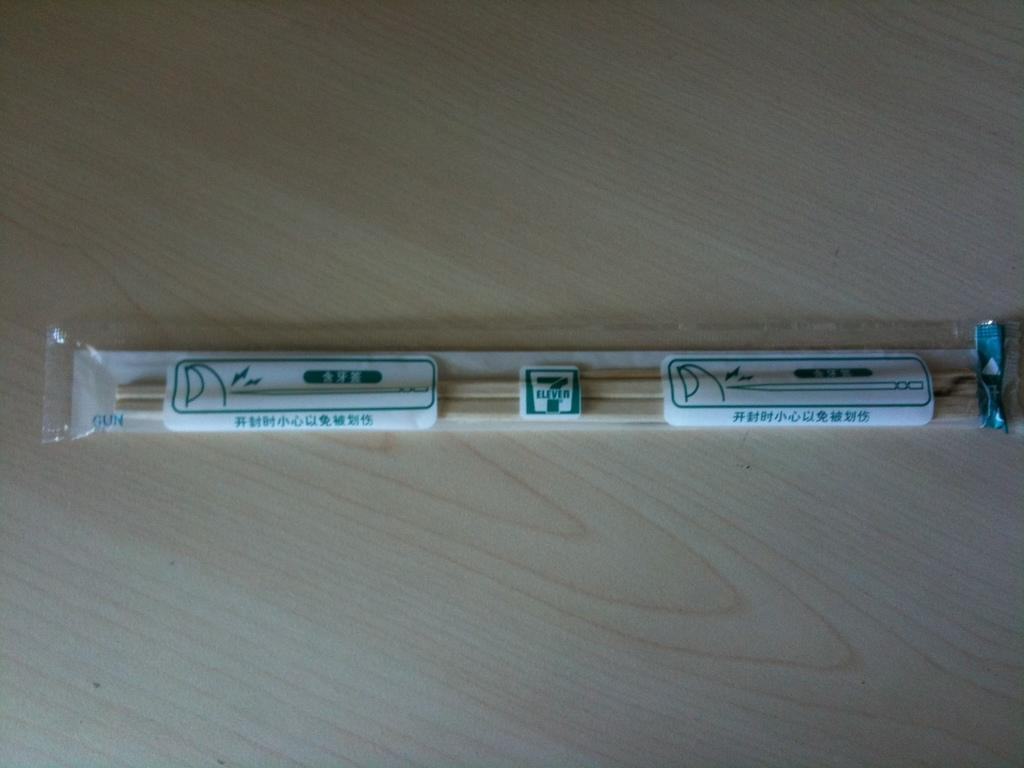What type of material is used for the cover in the image? There is a plastic cover in the image. What can be found inside the plastic cover? There are wooden chopsticks inside the plastic cover. How does the pig interact with the rain in the image? There is no pig or rain present in the image; it only features a plastic cover with wooden chopsticks inside. 